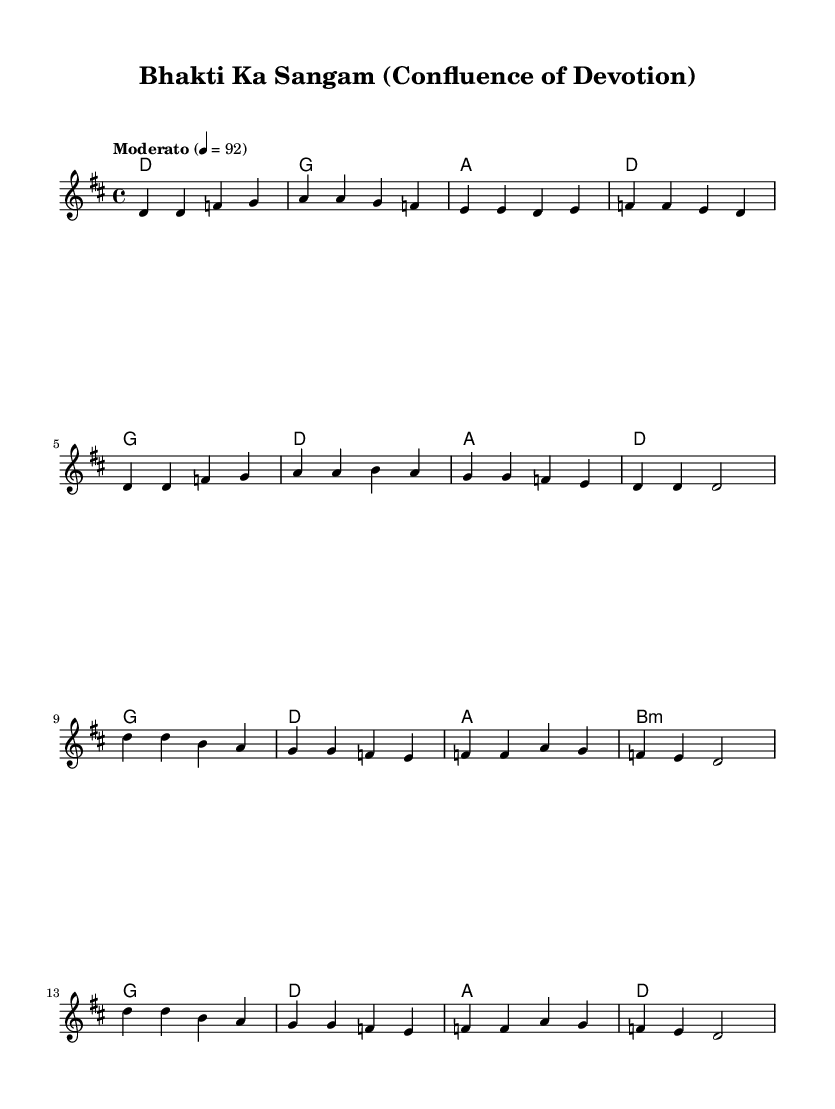What is the key signature of this music? The key signature is D major, which has two sharps: F# and C#.
Answer: D major What is the time signature of the piece? The time signature is 4/4, indicating four beats in a measure.
Answer: 4/4 What is the tempo marking of this music? The tempo marking is "Moderato," which indicates a moderate pace.
Answer: Moderato How many measures are there in the verse? There are eight measures in the verse section of the score.
Answer: Eight What chord comes after the second measure of the chorus? The chord following the second measure of the chorus is A.
Answer: A What is the last chord in the score? The last chord in the score is D, concluding the piece in the tonic key.
Answer: D Which melodic note is repeated in the chorus? The note D is prominently repeated throughout the chorus section.
Answer: D 